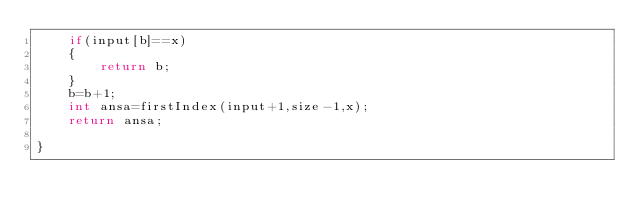Convert code to text. <code><loc_0><loc_0><loc_500><loc_500><_C++_>    if(input[b]==x)
    {
        return b;
    }
    b=b+1;
    int ansa=firstIndex(input+1,size-1,x);
    return ansa;
    
}
</code> 